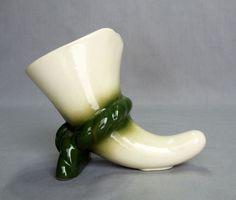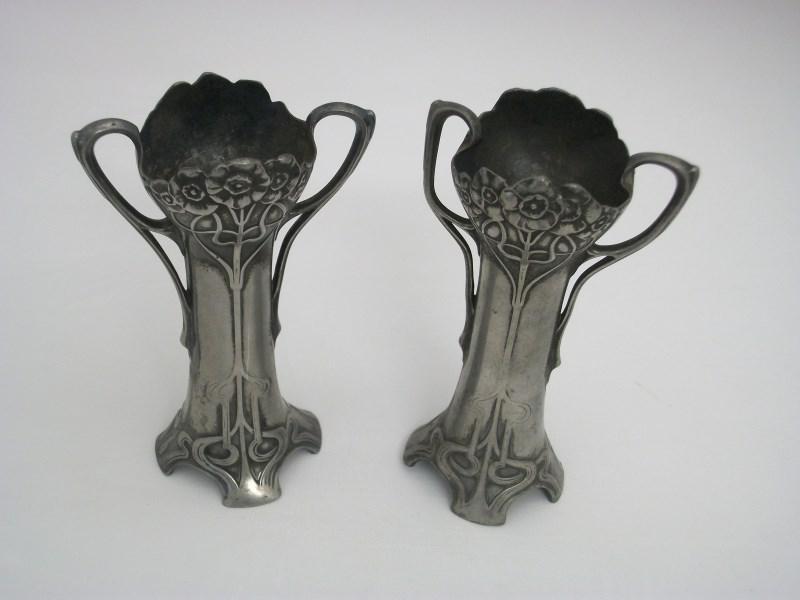The first image is the image on the left, the second image is the image on the right. Given the left and right images, does the statement "In one image, a vase with floral petal top design and scroll at the bottom is positioned in the center of a doily." hold true? Answer yes or no. No. The first image is the image on the left, the second image is the image on the right. Considering the images on both sides, is "The right image features a matched pair of vases." valid? Answer yes or no. Yes. 